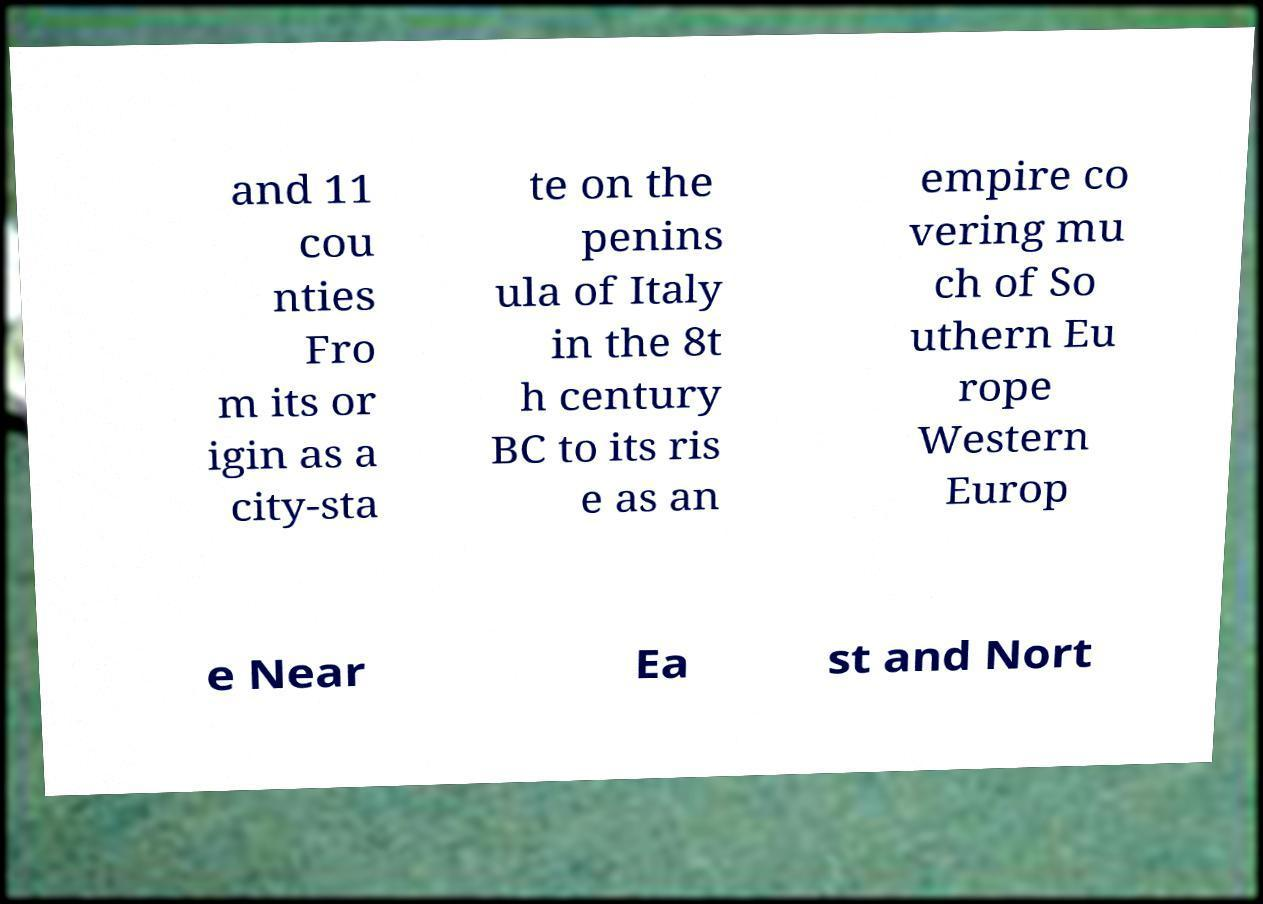Please identify and transcribe the text found in this image. and 11 cou nties Fro m its or igin as a city-sta te on the penins ula of Italy in the 8t h century BC to its ris e as an empire co vering mu ch of So uthern Eu rope Western Europ e Near Ea st and Nort 